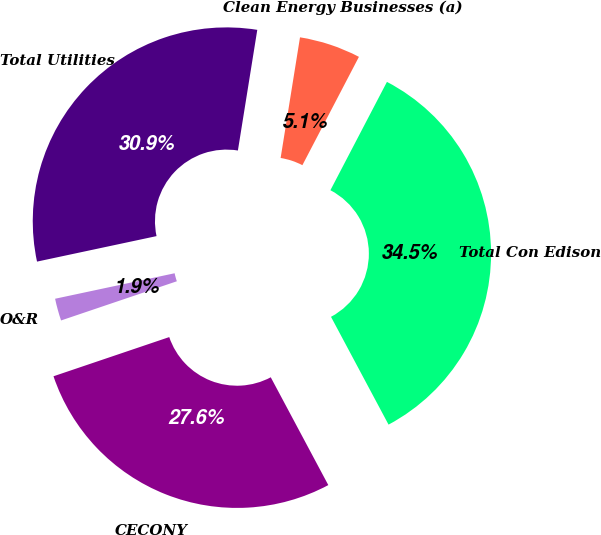Convert chart. <chart><loc_0><loc_0><loc_500><loc_500><pie_chart><fcel>CECONY<fcel>O&R<fcel>Total Utilities<fcel>Clean Energy Businesses (a)<fcel>Total Con Edison<nl><fcel>27.61%<fcel>1.85%<fcel>30.88%<fcel>5.12%<fcel>34.54%<nl></chart> 